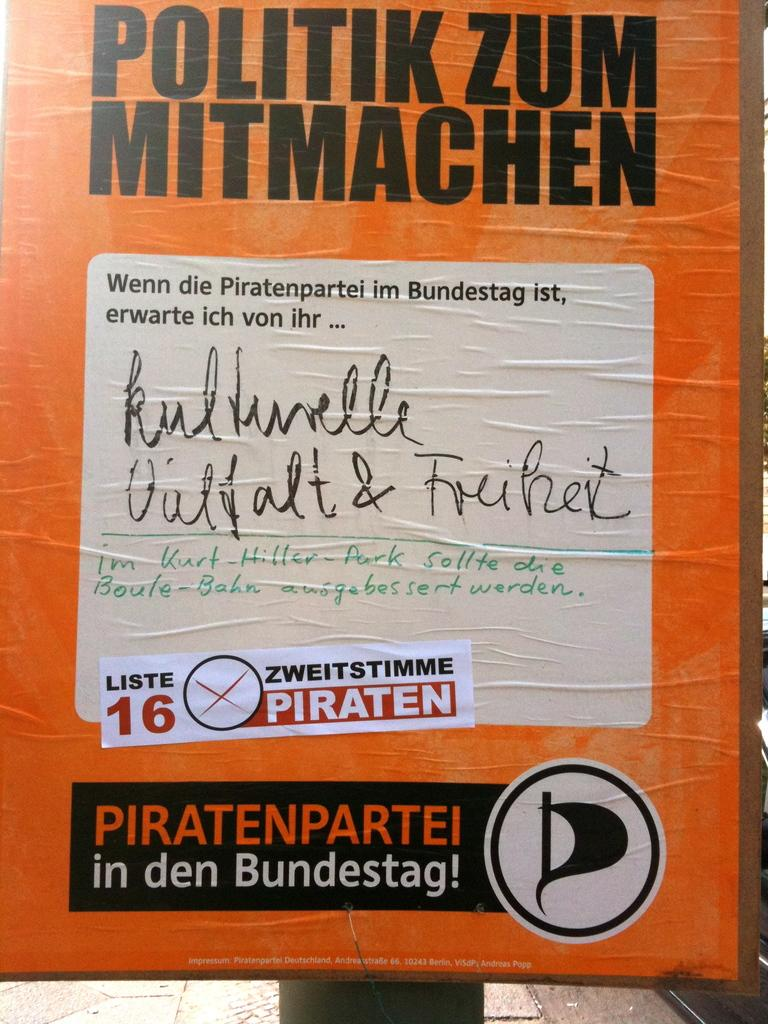What is the main object in the image? There is an orange board in the image. What is featured on the orange board? There is writing on the orange board. Can you see anyone slipping on the orange board in the image? There is no indication of anyone slipping on the orange board in the image. What type of gardening tool is present on the orange board? There is no gardening tool, such as a spade, present on the orange board in the image. 